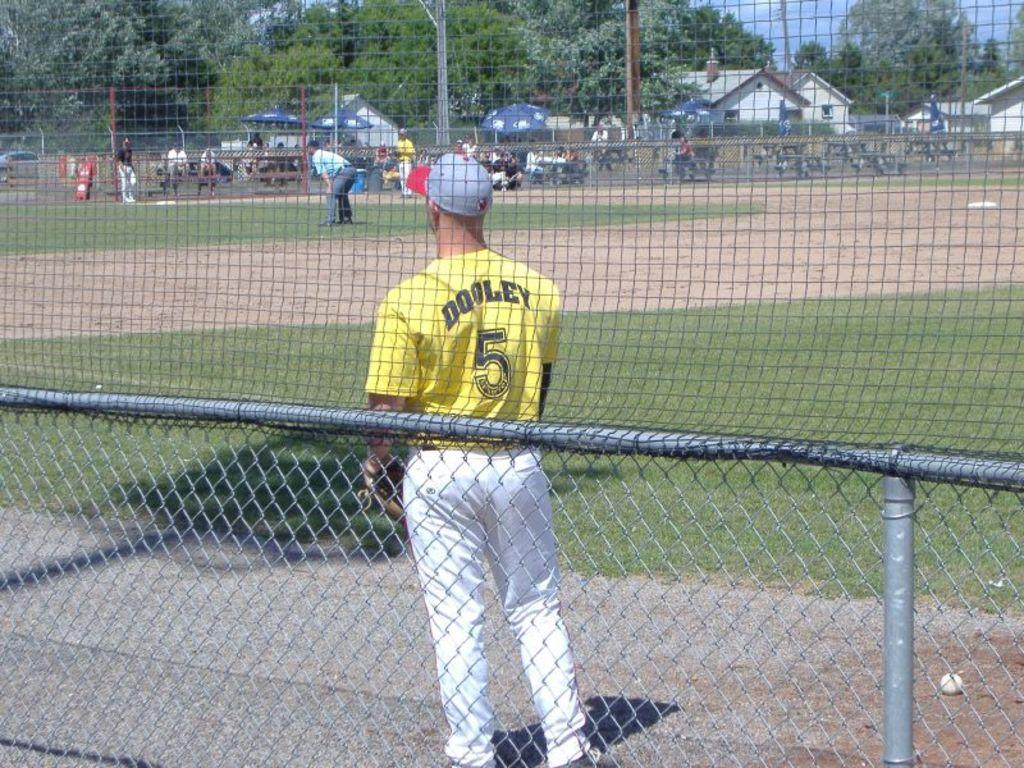<image>
Write a terse but informative summary of the picture. The baseball player in the yellow jersey is named Dooley. 